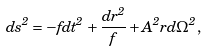Convert formula to latex. <formula><loc_0><loc_0><loc_500><loc_500>d s ^ { 2 } = - f d t ^ { 2 } + \frac { d r ^ { 2 } } { f } + A ^ { 2 } r d \Omega ^ { 2 } ,</formula> 